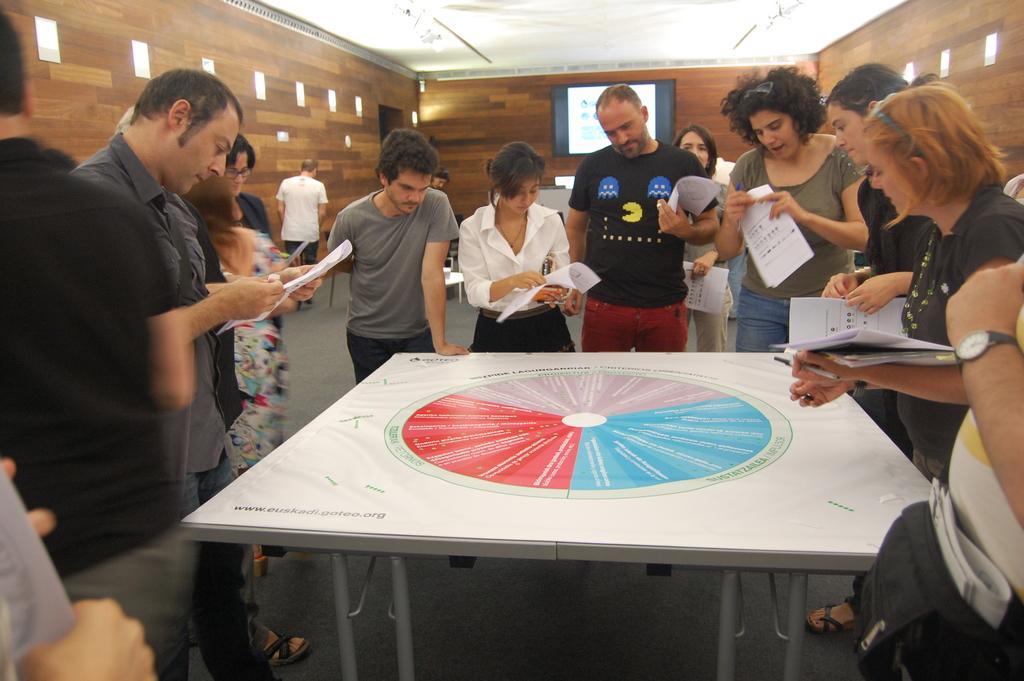Please provide a concise description of this image. In this picture we can see group of people, few people are holding papers in their hands, and watching a paper which is on the table. 